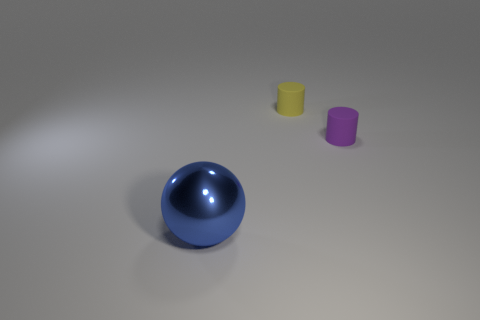How many things are either small matte things behind the purple cylinder or small things on the left side of the purple matte thing?
Provide a succinct answer. 1. What number of blue objects are either large matte cubes or big objects?
Your answer should be very brief. 1. What is the material of the thing that is both on the right side of the blue sphere and left of the tiny purple rubber thing?
Offer a terse response. Rubber. Do the big thing and the purple thing have the same material?
Your answer should be compact. No. What number of cylinders have the same size as the yellow matte thing?
Your answer should be compact. 1. Are there an equal number of matte objects that are behind the purple matte thing and tiny purple cylinders?
Provide a succinct answer. Yes. How many things are both behind the blue object and left of the purple matte thing?
Offer a terse response. 1. There is a object that is in front of the small purple rubber object; is its shape the same as the purple object?
Give a very brief answer. No. What is the material of the purple thing that is the same size as the yellow rubber object?
Your answer should be very brief. Rubber. Is the number of small rubber cylinders that are left of the tiny purple thing the same as the number of large blue shiny spheres that are on the right side of the yellow rubber thing?
Your answer should be very brief. No. 